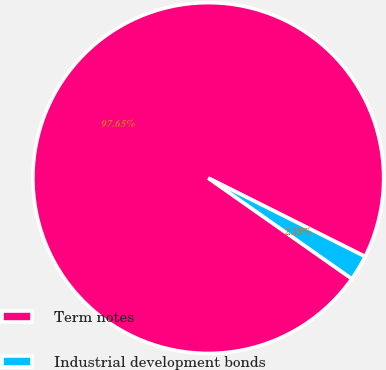<chart> <loc_0><loc_0><loc_500><loc_500><pie_chart><fcel>Term notes<fcel>Industrial development bonds<nl><fcel>97.65%<fcel>2.35%<nl></chart> 